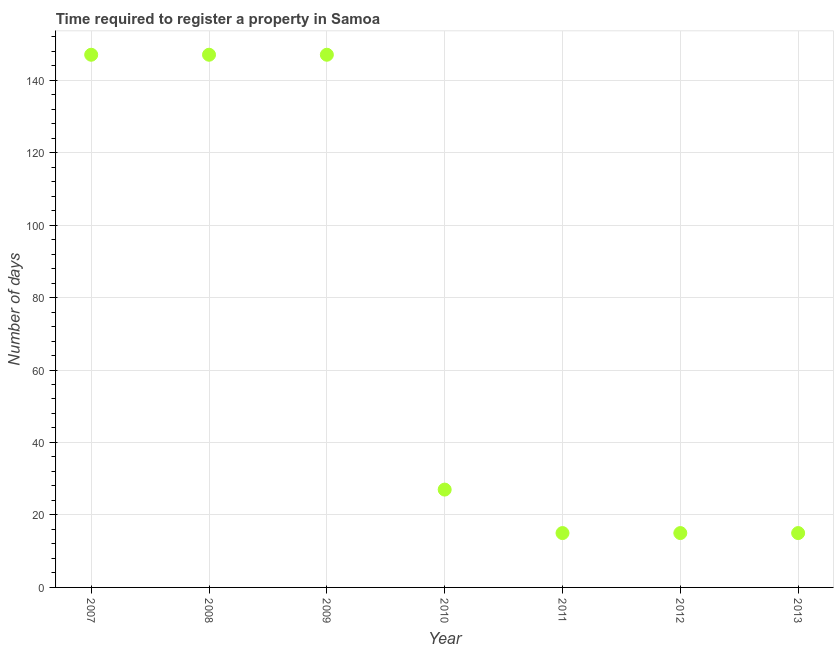What is the number of days required to register property in 2008?
Your response must be concise. 147. Across all years, what is the maximum number of days required to register property?
Keep it short and to the point. 147. Across all years, what is the minimum number of days required to register property?
Your response must be concise. 15. What is the sum of the number of days required to register property?
Your answer should be very brief. 513. What is the average number of days required to register property per year?
Give a very brief answer. 73.29. What is the median number of days required to register property?
Provide a short and direct response. 27. In how many years, is the number of days required to register property greater than 12 days?
Offer a very short reply. 7. Is the difference between the number of days required to register property in 2010 and 2011 greater than the difference between any two years?
Your answer should be very brief. No. What is the difference between the highest and the second highest number of days required to register property?
Your answer should be compact. 0. Is the sum of the number of days required to register property in 2008 and 2012 greater than the maximum number of days required to register property across all years?
Provide a short and direct response. Yes. What is the difference between the highest and the lowest number of days required to register property?
Provide a short and direct response. 132. What is the title of the graph?
Your answer should be compact. Time required to register a property in Samoa. What is the label or title of the Y-axis?
Your answer should be very brief. Number of days. What is the Number of days in 2007?
Offer a terse response. 147. What is the Number of days in 2008?
Offer a terse response. 147. What is the Number of days in 2009?
Provide a short and direct response. 147. What is the Number of days in 2010?
Give a very brief answer. 27. What is the Number of days in 2011?
Keep it short and to the point. 15. What is the Number of days in 2012?
Provide a succinct answer. 15. What is the Number of days in 2013?
Provide a short and direct response. 15. What is the difference between the Number of days in 2007 and 2010?
Ensure brevity in your answer.  120. What is the difference between the Number of days in 2007 and 2011?
Provide a short and direct response. 132. What is the difference between the Number of days in 2007 and 2012?
Your answer should be very brief. 132. What is the difference between the Number of days in 2007 and 2013?
Keep it short and to the point. 132. What is the difference between the Number of days in 2008 and 2009?
Your response must be concise. 0. What is the difference between the Number of days in 2008 and 2010?
Provide a succinct answer. 120. What is the difference between the Number of days in 2008 and 2011?
Provide a succinct answer. 132. What is the difference between the Number of days in 2008 and 2012?
Your answer should be compact. 132. What is the difference between the Number of days in 2008 and 2013?
Your response must be concise. 132. What is the difference between the Number of days in 2009 and 2010?
Your answer should be very brief. 120. What is the difference between the Number of days in 2009 and 2011?
Keep it short and to the point. 132. What is the difference between the Number of days in 2009 and 2012?
Give a very brief answer. 132. What is the difference between the Number of days in 2009 and 2013?
Offer a very short reply. 132. What is the difference between the Number of days in 2010 and 2012?
Your answer should be very brief. 12. What is the ratio of the Number of days in 2007 to that in 2008?
Your answer should be very brief. 1. What is the ratio of the Number of days in 2007 to that in 2009?
Ensure brevity in your answer.  1. What is the ratio of the Number of days in 2007 to that in 2010?
Keep it short and to the point. 5.44. What is the ratio of the Number of days in 2007 to that in 2011?
Keep it short and to the point. 9.8. What is the ratio of the Number of days in 2007 to that in 2012?
Your answer should be very brief. 9.8. What is the ratio of the Number of days in 2007 to that in 2013?
Your response must be concise. 9.8. What is the ratio of the Number of days in 2008 to that in 2010?
Provide a short and direct response. 5.44. What is the ratio of the Number of days in 2008 to that in 2011?
Your response must be concise. 9.8. What is the ratio of the Number of days in 2009 to that in 2010?
Provide a short and direct response. 5.44. What is the ratio of the Number of days in 2009 to that in 2012?
Make the answer very short. 9.8. What is the ratio of the Number of days in 2010 to that in 2011?
Give a very brief answer. 1.8. What is the ratio of the Number of days in 2010 to that in 2012?
Offer a terse response. 1.8. What is the ratio of the Number of days in 2011 to that in 2012?
Offer a terse response. 1. 